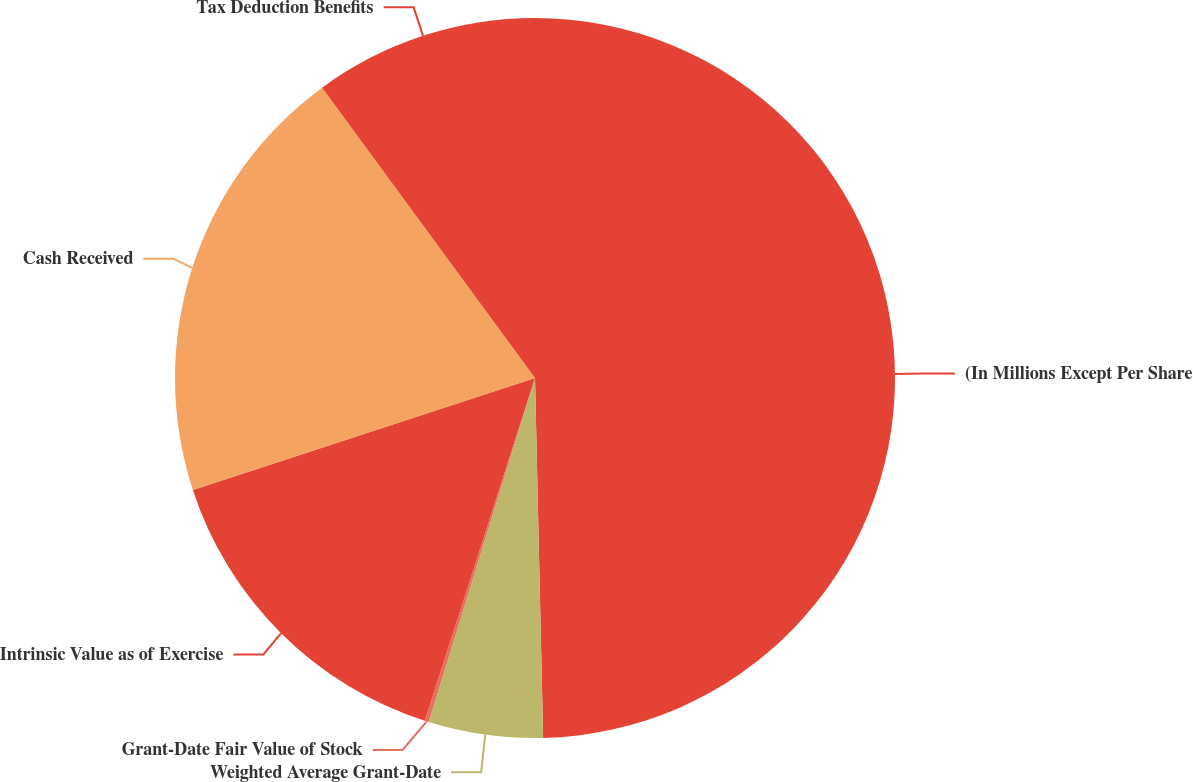Convert chart. <chart><loc_0><loc_0><loc_500><loc_500><pie_chart><fcel>(In Millions Except Per Share<fcel>Weighted Average Grant-Date<fcel>Grant-Date Fair Value of Stock<fcel>Intrinsic Value as of Exercise<fcel>Cash Received<fcel>Tax Deduction Benefits<nl><fcel>49.64%<fcel>5.13%<fcel>0.18%<fcel>15.02%<fcel>19.96%<fcel>10.07%<nl></chart> 